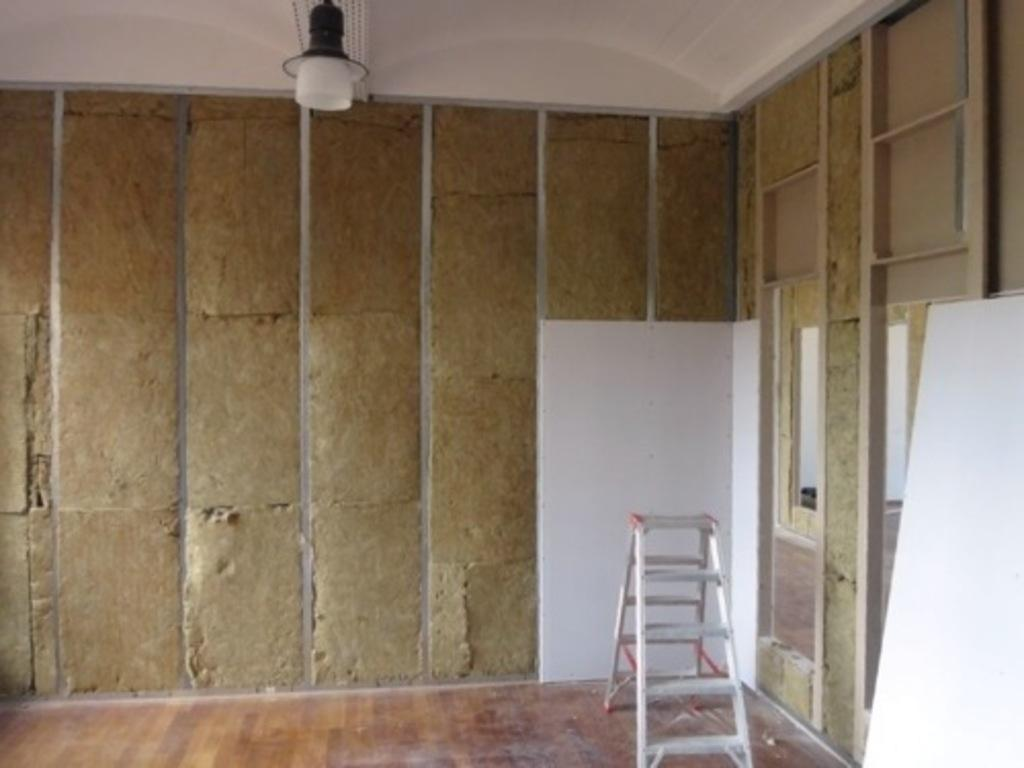What is the main object in the image? A: There is a ladder in the image. What is located behind the ladder? There is a wall in the image. What is hanging from the ceiling in the image? There are objects attached to the ceiling in the image. What type of surface can be seen in the image? There are white color boards in the image. Can you tell me what book your aunt is reading in the image? There is no book or aunt present in the image; it only features a ladder, a wall, objects attached to the ceiling, and white color boards. 